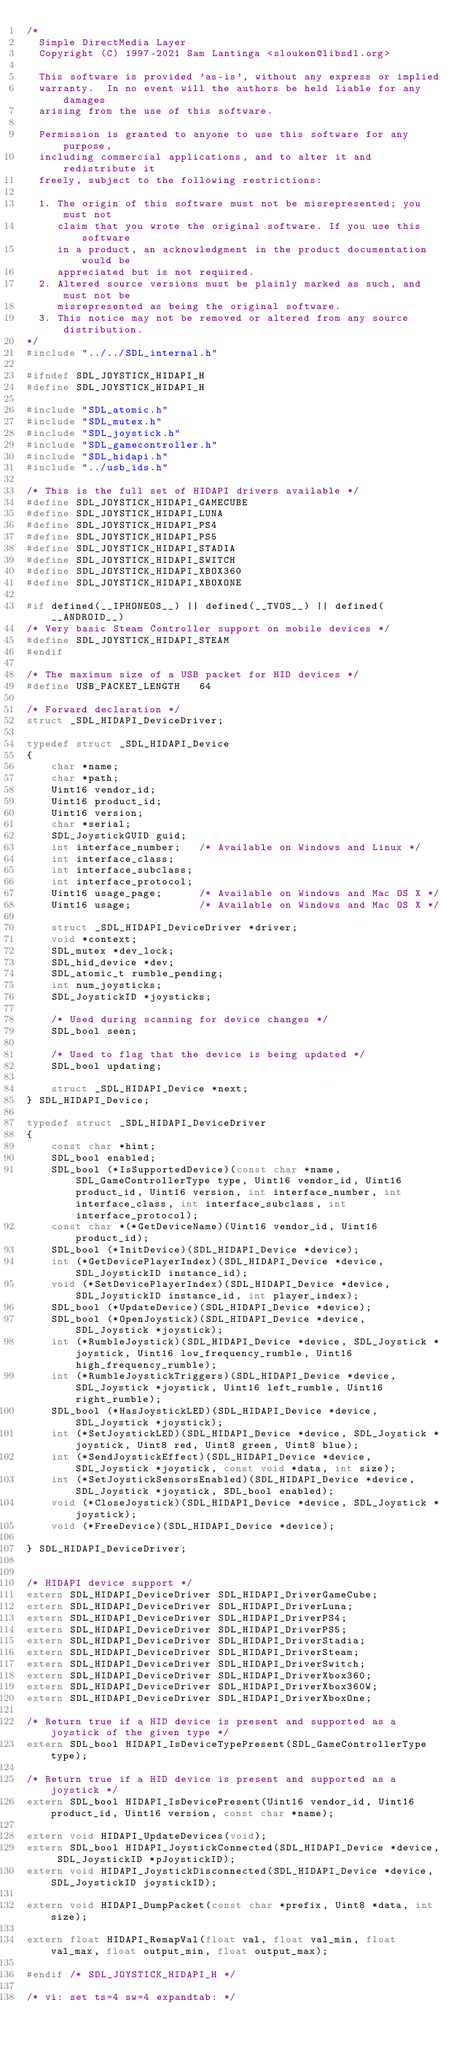Convert code to text. <code><loc_0><loc_0><loc_500><loc_500><_C_>/*
  Simple DirectMedia Layer
  Copyright (C) 1997-2021 Sam Lantinga <slouken@libsdl.org>

  This software is provided 'as-is', without any express or implied
  warranty.  In no event will the authors be held liable for any damages
  arising from the use of this software.

  Permission is granted to anyone to use this software for any purpose,
  including commercial applications, and to alter it and redistribute it
  freely, subject to the following restrictions:

  1. The origin of this software must not be misrepresented; you must not
     claim that you wrote the original software. If you use this software
     in a product, an acknowledgment in the product documentation would be
     appreciated but is not required.
  2. Altered source versions must be plainly marked as such, and must not be
     misrepresented as being the original software.
  3. This notice may not be removed or altered from any source distribution.
*/
#include "../../SDL_internal.h"

#ifndef SDL_JOYSTICK_HIDAPI_H
#define SDL_JOYSTICK_HIDAPI_H

#include "SDL_atomic.h"
#include "SDL_mutex.h"
#include "SDL_joystick.h"
#include "SDL_gamecontroller.h"
#include "SDL_hidapi.h"
#include "../usb_ids.h"

/* This is the full set of HIDAPI drivers available */
#define SDL_JOYSTICK_HIDAPI_GAMECUBE
#define SDL_JOYSTICK_HIDAPI_LUNA
#define SDL_JOYSTICK_HIDAPI_PS4
#define SDL_JOYSTICK_HIDAPI_PS5
#define SDL_JOYSTICK_HIDAPI_STADIA
#define SDL_JOYSTICK_HIDAPI_SWITCH
#define SDL_JOYSTICK_HIDAPI_XBOX360
#define SDL_JOYSTICK_HIDAPI_XBOXONE

#if defined(__IPHONEOS__) || defined(__TVOS__) || defined(__ANDROID__)
/* Very basic Steam Controller support on mobile devices */
#define SDL_JOYSTICK_HIDAPI_STEAM
#endif

/* The maximum size of a USB packet for HID devices */
#define USB_PACKET_LENGTH   64

/* Forward declaration */
struct _SDL_HIDAPI_DeviceDriver;

typedef struct _SDL_HIDAPI_Device
{
    char *name;
    char *path;
    Uint16 vendor_id;
    Uint16 product_id;
    Uint16 version;
    char *serial;
    SDL_JoystickGUID guid;
    int interface_number;   /* Available on Windows and Linux */
    int interface_class;
    int interface_subclass;
    int interface_protocol;
    Uint16 usage_page;      /* Available on Windows and Mac OS X */
    Uint16 usage;           /* Available on Windows and Mac OS X */

    struct _SDL_HIDAPI_DeviceDriver *driver;
    void *context;
    SDL_mutex *dev_lock;
    SDL_hid_device *dev;
    SDL_atomic_t rumble_pending;
    int num_joysticks;
    SDL_JoystickID *joysticks;

    /* Used during scanning for device changes */
    SDL_bool seen;

    /* Used to flag that the device is being updated */
    SDL_bool updating;

    struct _SDL_HIDAPI_Device *next;
} SDL_HIDAPI_Device;

typedef struct _SDL_HIDAPI_DeviceDriver
{
    const char *hint;
    SDL_bool enabled;
    SDL_bool (*IsSupportedDevice)(const char *name, SDL_GameControllerType type, Uint16 vendor_id, Uint16 product_id, Uint16 version, int interface_number, int interface_class, int interface_subclass, int interface_protocol);
    const char *(*GetDeviceName)(Uint16 vendor_id, Uint16 product_id);
    SDL_bool (*InitDevice)(SDL_HIDAPI_Device *device);
    int (*GetDevicePlayerIndex)(SDL_HIDAPI_Device *device, SDL_JoystickID instance_id);
    void (*SetDevicePlayerIndex)(SDL_HIDAPI_Device *device, SDL_JoystickID instance_id, int player_index);
    SDL_bool (*UpdateDevice)(SDL_HIDAPI_Device *device);
    SDL_bool (*OpenJoystick)(SDL_HIDAPI_Device *device, SDL_Joystick *joystick);
    int (*RumbleJoystick)(SDL_HIDAPI_Device *device, SDL_Joystick *joystick, Uint16 low_frequency_rumble, Uint16 high_frequency_rumble);
    int (*RumbleJoystickTriggers)(SDL_HIDAPI_Device *device, SDL_Joystick *joystick, Uint16 left_rumble, Uint16 right_rumble);
    SDL_bool (*HasJoystickLED)(SDL_HIDAPI_Device *device, SDL_Joystick *joystick);
    int (*SetJoystickLED)(SDL_HIDAPI_Device *device, SDL_Joystick *joystick, Uint8 red, Uint8 green, Uint8 blue);
    int (*SendJoystickEffect)(SDL_HIDAPI_Device *device, SDL_Joystick *joystick, const void *data, int size);
    int (*SetJoystickSensorsEnabled)(SDL_HIDAPI_Device *device, SDL_Joystick *joystick, SDL_bool enabled);
    void (*CloseJoystick)(SDL_HIDAPI_Device *device, SDL_Joystick *joystick);
    void (*FreeDevice)(SDL_HIDAPI_Device *device);

} SDL_HIDAPI_DeviceDriver;


/* HIDAPI device support */
extern SDL_HIDAPI_DeviceDriver SDL_HIDAPI_DriverGameCube;
extern SDL_HIDAPI_DeviceDriver SDL_HIDAPI_DriverLuna;
extern SDL_HIDAPI_DeviceDriver SDL_HIDAPI_DriverPS4;
extern SDL_HIDAPI_DeviceDriver SDL_HIDAPI_DriverPS5;
extern SDL_HIDAPI_DeviceDriver SDL_HIDAPI_DriverStadia;
extern SDL_HIDAPI_DeviceDriver SDL_HIDAPI_DriverSteam;
extern SDL_HIDAPI_DeviceDriver SDL_HIDAPI_DriverSwitch;
extern SDL_HIDAPI_DeviceDriver SDL_HIDAPI_DriverXbox360;
extern SDL_HIDAPI_DeviceDriver SDL_HIDAPI_DriverXbox360W;
extern SDL_HIDAPI_DeviceDriver SDL_HIDAPI_DriverXboxOne;

/* Return true if a HID device is present and supported as a joystick of the given type */
extern SDL_bool HIDAPI_IsDeviceTypePresent(SDL_GameControllerType type);

/* Return true if a HID device is present and supported as a joystick */
extern SDL_bool HIDAPI_IsDevicePresent(Uint16 vendor_id, Uint16 product_id, Uint16 version, const char *name);

extern void HIDAPI_UpdateDevices(void);
extern SDL_bool HIDAPI_JoystickConnected(SDL_HIDAPI_Device *device, SDL_JoystickID *pJoystickID);
extern void HIDAPI_JoystickDisconnected(SDL_HIDAPI_Device *device, SDL_JoystickID joystickID);

extern void HIDAPI_DumpPacket(const char *prefix, Uint8 *data, int size);

extern float HIDAPI_RemapVal(float val, float val_min, float val_max, float output_min, float output_max);

#endif /* SDL_JOYSTICK_HIDAPI_H */

/* vi: set ts=4 sw=4 expandtab: */
</code> 